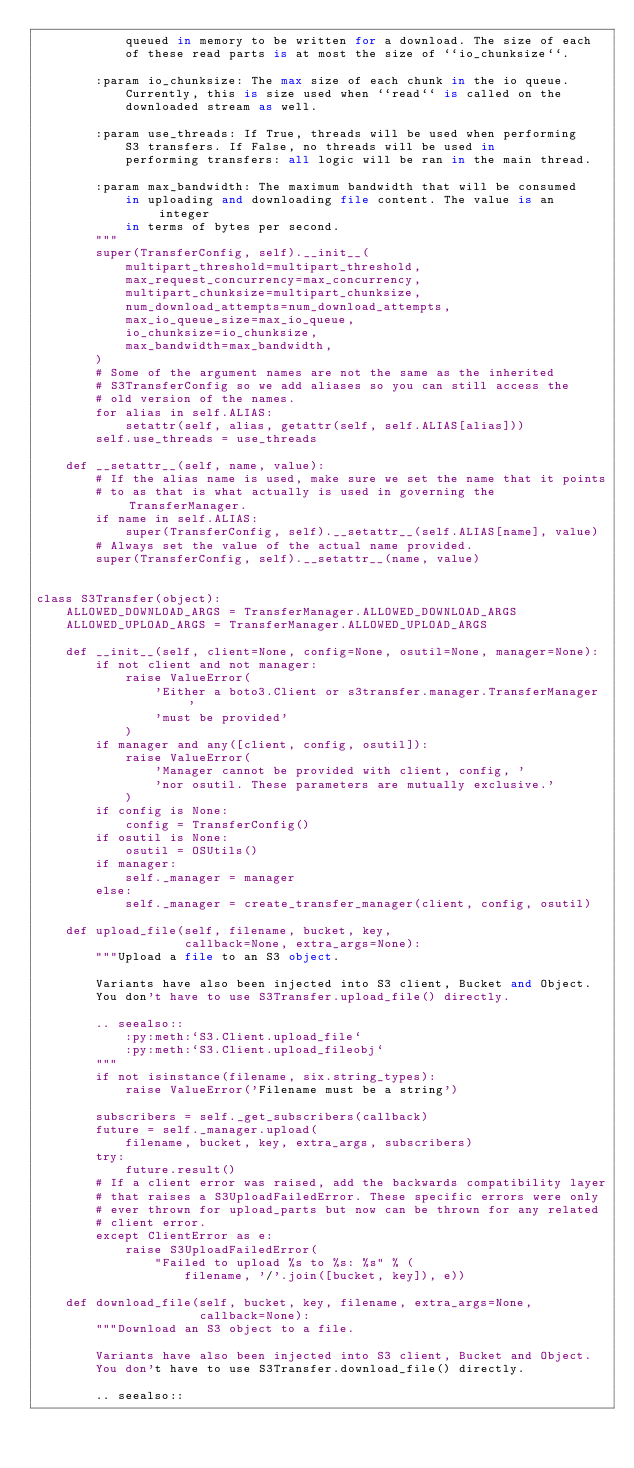Convert code to text. <code><loc_0><loc_0><loc_500><loc_500><_Python_>            queued in memory to be written for a download. The size of each
            of these read parts is at most the size of ``io_chunksize``.

        :param io_chunksize: The max size of each chunk in the io queue.
            Currently, this is size used when ``read`` is called on the
            downloaded stream as well.

        :param use_threads: If True, threads will be used when performing
            S3 transfers. If False, no threads will be used in
            performing transfers: all logic will be ran in the main thread.

        :param max_bandwidth: The maximum bandwidth that will be consumed
            in uploading and downloading file content. The value is an integer
            in terms of bytes per second.
        """
        super(TransferConfig, self).__init__(
            multipart_threshold=multipart_threshold,
            max_request_concurrency=max_concurrency,
            multipart_chunksize=multipart_chunksize,
            num_download_attempts=num_download_attempts,
            max_io_queue_size=max_io_queue,
            io_chunksize=io_chunksize,
            max_bandwidth=max_bandwidth,
        )
        # Some of the argument names are not the same as the inherited
        # S3TransferConfig so we add aliases so you can still access the
        # old version of the names.
        for alias in self.ALIAS:
            setattr(self, alias, getattr(self, self.ALIAS[alias]))
        self.use_threads = use_threads

    def __setattr__(self, name, value):
        # If the alias name is used, make sure we set the name that it points
        # to as that is what actually is used in governing the TransferManager.
        if name in self.ALIAS:
            super(TransferConfig, self).__setattr__(self.ALIAS[name], value)
        # Always set the value of the actual name provided.
        super(TransferConfig, self).__setattr__(name, value)


class S3Transfer(object):
    ALLOWED_DOWNLOAD_ARGS = TransferManager.ALLOWED_DOWNLOAD_ARGS
    ALLOWED_UPLOAD_ARGS = TransferManager.ALLOWED_UPLOAD_ARGS

    def __init__(self, client=None, config=None, osutil=None, manager=None):
        if not client and not manager:
            raise ValueError(
                'Either a boto3.Client or s3transfer.manager.TransferManager '
                'must be provided'
            )
        if manager and any([client, config, osutil]):
            raise ValueError(
                'Manager cannot be provided with client, config, '
                'nor osutil. These parameters are mutually exclusive.'
            )
        if config is None:
            config = TransferConfig()
        if osutil is None:
            osutil = OSUtils()
        if manager:
            self._manager = manager
        else:
            self._manager = create_transfer_manager(client, config, osutil)

    def upload_file(self, filename, bucket, key,
                    callback=None, extra_args=None):
        """Upload a file to an S3 object.

        Variants have also been injected into S3 client, Bucket and Object.
        You don't have to use S3Transfer.upload_file() directly.

        .. seealso::
            :py:meth:`S3.Client.upload_file`
            :py:meth:`S3.Client.upload_fileobj`
        """
        if not isinstance(filename, six.string_types):
            raise ValueError('Filename must be a string')

        subscribers = self._get_subscribers(callback)
        future = self._manager.upload(
            filename, bucket, key, extra_args, subscribers)
        try:
            future.result()
        # If a client error was raised, add the backwards compatibility layer
        # that raises a S3UploadFailedError. These specific errors were only
        # ever thrown for upload_parts but now can be thrown for any related
        # client error.
        except ClientError as e:
            raise S3UploadFailedError(
                "Failed to upload %s to %s: %s" % (
                    filename, '/'.join([bucket, key]), e))

    def download_file(self, bucket, key, filename, extra_args=None,
                      callback=None):
        """Download an S3 object to a file.

        Variants have also been injected into S3 client, Bucket and Object.
        You don't have to use S3Transfer.download_file() directly.

        .. seealso::</code> 